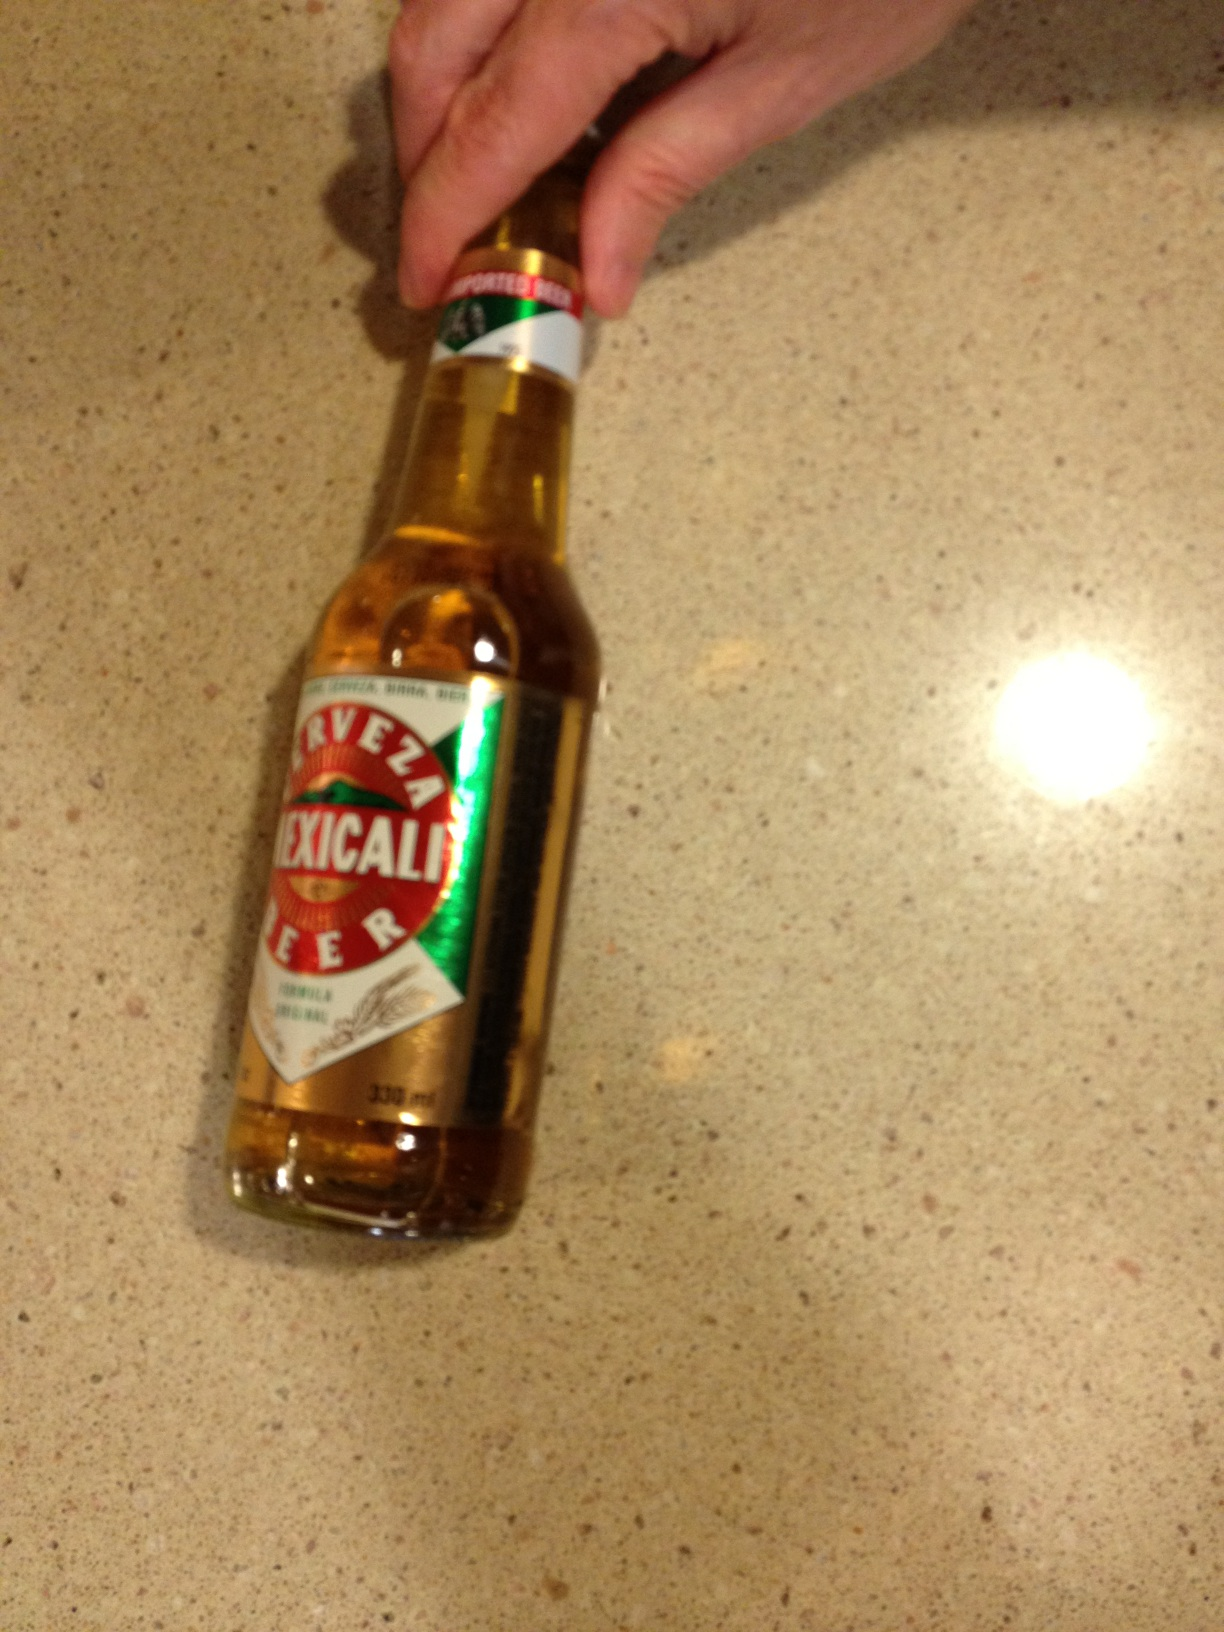What is the alcohol percentage in this beer? Mexicali beer usually has an alcohol content around 4.5% to 6.0%. It provides a smooth experience with just the right kick. 